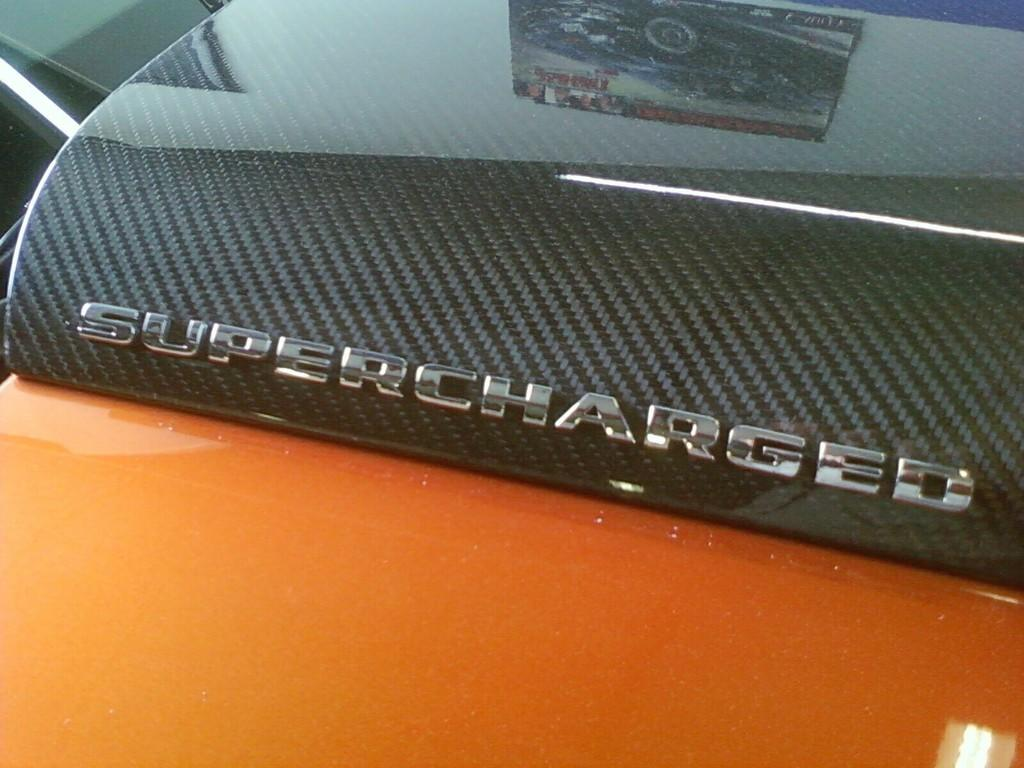What is the main object in the image? There is a device in the image. What is the color of the table the device is on? The table is orange. What phrase is written on the device? The words "super charged" are written on the device. Can you see a dog playing in the background of the image? There is no dog or background visible in the image; it only shows a device on an orange table. 